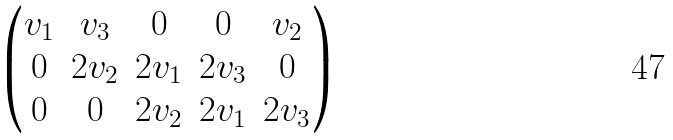Convert formula to latex. <formula><loc_0><loc_0><loc_500><loc_500>\begin{pmatrix} v _ { 1 } & v _ { 3 } & 0 & 0 & v _ { 2 } \\ 0 & 2 v _ { 2 } & 2 v _ { 1 } & 2 v _ { 3 } & 0 \\ 0 & 0 & 2 v _ { 2 } & 2 v _ { 1 } & 2 v _ { 3 } \end{pmatrix}</formula> 